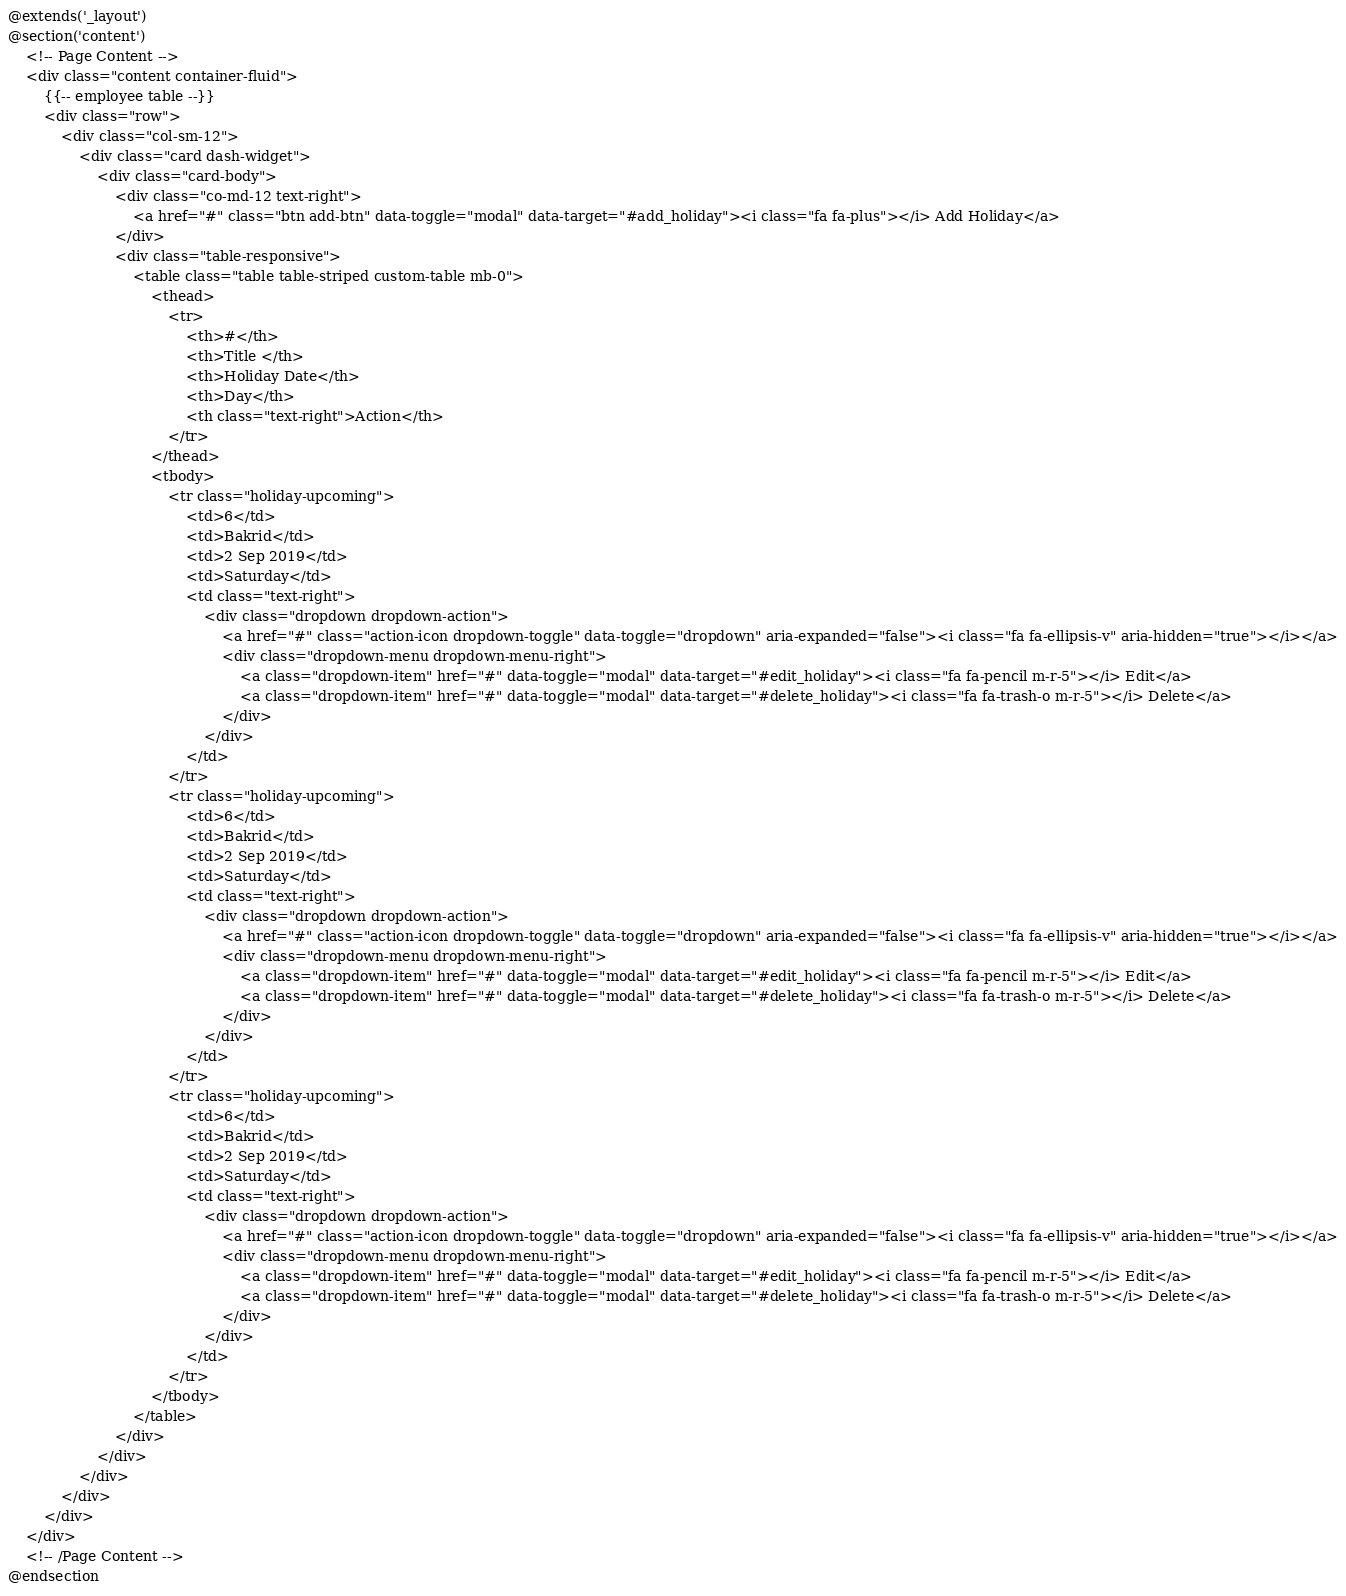Convert code to text. <code><loc_0><loc_0><loc_500><loc_500><_PHP_>@extends('_layout')
@section('content')
    <!-- Page Content -->
    <div class="content container-fluid">
        {{-- employee table --}}
		<div class="row">
			<div class="col-sm-12">
				<div class="card dash-widget">
					<div class="card-body">
						<div class="co-md-12 text-right">
							<a href="#" class="btn add-btn" data-toggle="modal" data-target="#add_holiday"><i class="fa fa-plus"></i> Add Holiday</a>
						</div>
						<div class="table-responsive">
							<table class="table table-striped custom-table mb-0">
								<thead>
									<tr>
										<th>#</th>
										<th>Title </th>
										<th>Holiday Date</th>
										<th>Day</th>
										<th class="text-right">Action</th>
									</tr>
								</thead>
								<tbody>
									<tr class="holiday-upcoming">
										<td>6</td>
										<td>Bakrid</td>
										<td>2 Sep 2019</td>
										<td>Saturday</td>
										<td class="text-right">
											<div class="dropdown dropdown-action">
												<a href="#" class="action-icon dropdown-toggle" data-toggle="dropdown" aria-expanded="false"><i class="fa fa-ellipsis-v" aria-hidden="true"></i></a>
												<div class="dropdown-menu dropdown-menu-right">
													<a class="dropdown-item" href="#" data-toggle="modal" data-target="#edit_holiday"><i class="fa fa-pencil m-r-5"></i> Edit</a>
													<a class="dropdown-item" href="#" data-toggle="modal" data-target="#delete_holiday"><i class="fa fa-trash-o m-r-5"></i> Delete</a>
												</div>
											</div>
										</td>
									</tr>
									<tr class="holiday-upcoming">
										<td>6</td>
										<td>Bakrid</td>
										<td>2 Sep 2019</td>
										<td>Saturday</td>
										<td class="text-right">
											<div class="dropdown dropdown-action">
												<a href="#" class="action-icon dropdown-toggle" data-toggle="dropdown" aria-expanded="false"><i class="fa fa-ellipsis-v" aria-hidden="true"></i></a>
												<div class="dropdown-menu dropdown-menu-right">
													<a class="dropdown-item" href="#" data-toggle="modal" data-target="#edit_holiday"><i class="fa fa-pencil m-r-5"></i> Edit</a>
													<a class="dropdown-item" href="#" data-toggle="modal" data-target="#delete_holiday"><i class="fa fa-trash-o m-r-5"></i> Delete</a>
												</div>
											</div>
										</td>
									</tr>
									<tr class="holiday-upcoming">
										<td>6</td>
										<td>Bakrid</td>
										<td>2 Sep 2019</td>
										<td>Saturday</td>
										<td class="text-right">
											<div class="dropdown dropdown-action">
												<a href="#" class="action-icon dropdown-toggle" data-toggle="dropdown" aria-expanded="false"><i class="fa fa-ellipsis-v" aria-hidden="true"></i></a>
												<div class="dropdown-menu dropdown-menu-right">
													<a class="dropdown-item" href="#" data-toggle="modal" data-target="#edit_holiday"><i class="fa fa-pencil m-r-5"></i> Edit</a>
													<a class="dropdown-item" href="#" data-toggle="modal" data-target="#delete_holiday"><i class="fa fa-trash-o m-r-5"></i> Delete</a>
												</div>
											</div>
										</td>
									</tr>
								</tbody>
							</table>
						</div>
					</div>
				</div>
			</div>
		</div>
	</div>
	<!-- /Page Content -->
@endsection</code> 